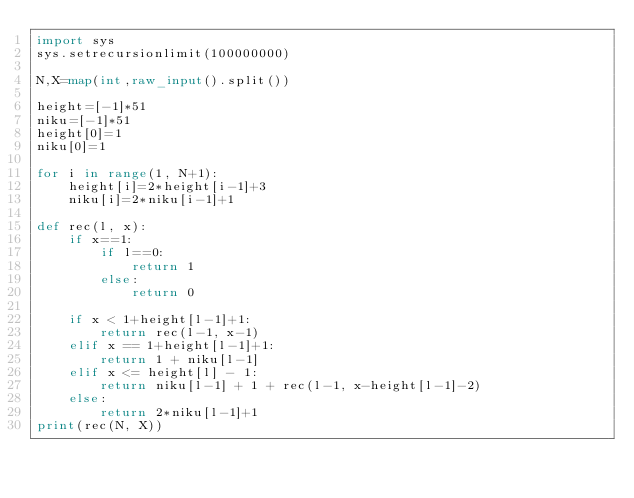Convert code to text. <code><loc_0><loc_0><loc_500><loc_500><_Python_>import sys
sys.setrecursionlimit(100000000)

N,X=map(int,raw_input().split())

height=[-1]*51
niku=[-1]*51
height[0]=1
niku[0]=1

for i in range(1, N+1):
    height[i]=2*height[i-1]+3
    niku[i]=2*niku[i-1]+1

def rec(l, x):
    if x==1:
        if l==0:
            return 1
        else:
            return 0
    
    if x < 1+height[l-1]+1:
        return rec(l-1, x-1)
    elif x == 1+height[l-1]+1:
        return 1 + niku[l-1]
    elif x <= height[l] - 1:
        return niku[l-1] + 1 + rec(l-1, x-height[l-1]-2)
    else:
        return 2*niku[l-1]+1
print(rec(N, X))



    

</code> 